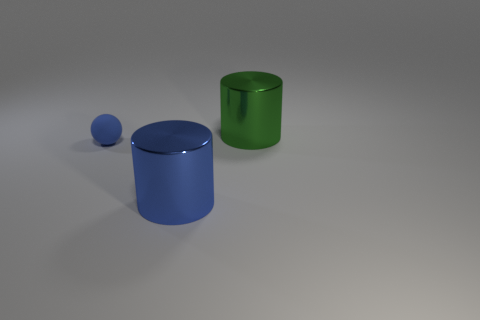How many rubber things are blue objects or big things?
Ensure brevity in your answer.  1. There is a large object in front of the rubber thing; how many rubber balls are in front of it?
Your answer should be compact. 0. What number of green cylinders are made of the same material as the small ball?
Offer a very short reply. 0. How many tiny things are either cyan metal objects or matte spheres?
Give a very brief answer. 1. What is the shape of the thing that is in front of the big green cylinder and right of the tiny rubber sphere?
Your response must be concise. Cylinder. Do the big blue thing and the big green cylinder have the same material?
Provide a succinct answer. Yes. What color is the metal cylinder that is the same size as the green metal object?
Your answer should be very brief. Blue. What color is the object that is right of the blue sphere and behind the big blue cylinder?
Offer a terse response. Green. There is a big metal object that is the same color as the rubber object; what shape is it?
Offer a terse response. Cylinder. There is a sphere in front of the big metallic thing behind the large metal object to the left of the big green metallic cylinder; what size is it?
Provide a short and direct response. Small. 